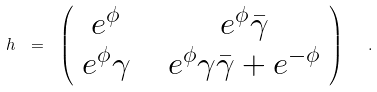<formula> <loc_0><loc_0><loc_500><loc_500>h \ = \ \left ( \begin{array} { c c } e ^ { \phi } \ & \ e ^ { \phi } \bar { \gamma } \\ e ^ { \phi } \gamma \ & \ e ^ { \phi } \gamma \bar { \gamma } + e ^ { - \phi } \end{array} \right ) \ \ .</formula> 